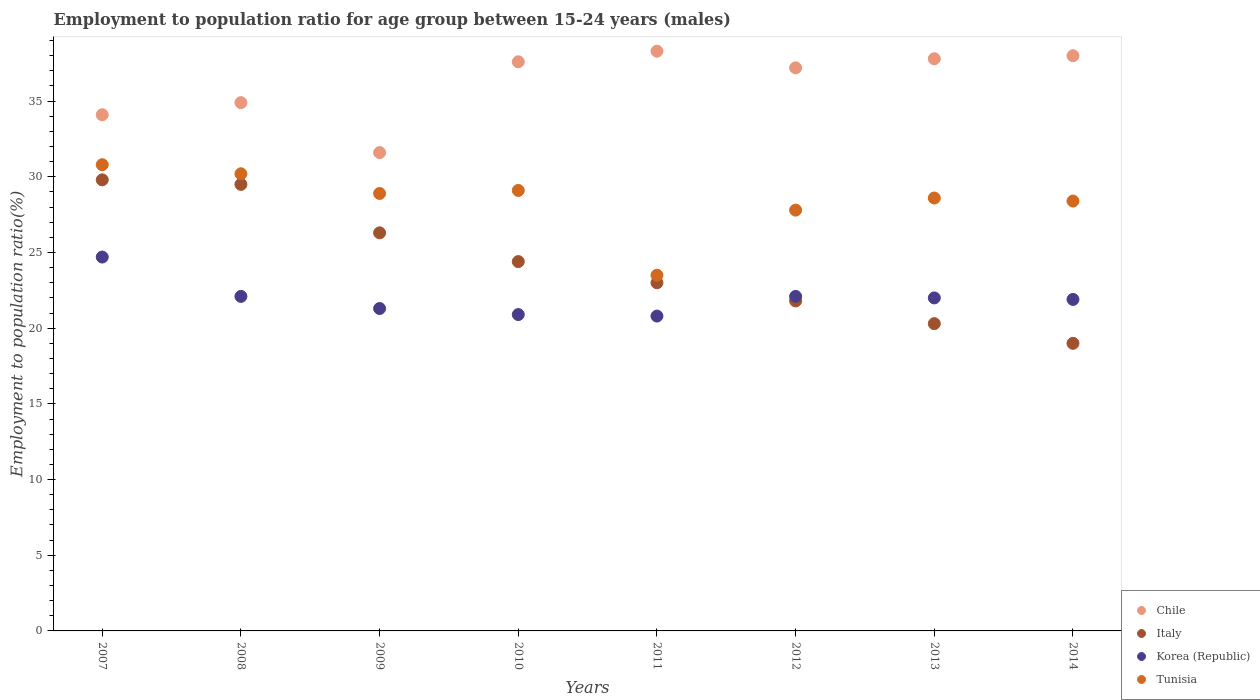Is the number of dotlines equal to the number of legend labels?
Your answer should be compact. Yes. What is the employment to population ratio in Italy in 2014?
Your answer should be very brief. 19. Across all years, what is the maximum employment to population ratio in Italy?
Your response must be concise. 29.8. Across all years, what is the minimum employment to population ratio in Korea (Republic)?
Your answer should be very brief. 20.8. In which year was the employment to population ratio in Korea (Republic) minimum?
Your answer should be very brief. 2011. What is the total employment to population ratio in Italy in the graph?
Your answer should be very brief. 194.1. What is the difference between the employment to population ratio in Korea (Republic) in 2011 and that in 2013?
Make the answer very short. -1.2. What is the difference between the employment to population ratio in Korea (Republic) in 2011 and the employment to population ratio in Italy in 2008?
Ensure brevity in your answer.  -8.7. What is the average employment to population ratio in Tunisia per year?
Offer a very short reply. 28.41. In the year 2011, what is the difference between the employment to population ratio in Italy and employment to population ratio in Korea (Republic)?
Make the answer very short. 2.2. What is the ratio of the employment to population ratio in Tunisia in 2008 to that in 2009?
Your answer should be very brief. 1.04. What is the difference between the highest and the second highest employment to population ratio in Chile?
Your answer should be very brief. 0.3. What is the difference between the highest and the lowest employment to population ratio in Korea (Republic)?
Offer a very short reply. 3.9. Is the sum of the employment to population ratio in Chile in 2007 and 2011 greater than the maximum employment to population ratio in Italy across all years?
Ensure brevity in your answer.  Yes. Is it the case that in every year, the sum of the employment to population ratio in Chile and employment to population ratio in Tunisia  is greater than the employment to population ratio in Korea (Republic)?
Your response must be concise. Yes. Does the employment to population ratio in Tunisia monotonically increase over the years?
Your response must be concise. No. Is the employment to population ratio in Chile strictly greater than the employment to population ratio in Tunisia over the years?
Your answer should be very brief. Yes. Are the values on the major ticks of Y-axis written in scientific E-notation?
Offer a very short reply. No. Does the graph contain any zero values?
Keep it short and to the point. No. How are the legend labels stacked?
Your response must be concise. Vertical. What is the title of the graph?
Offer a terse response. Employment to population ratio for age group between 15-24 years (males). Does "Middle East & North Africa (all income levels)" appear as one of the legend labels in the graph?
Your answer should be very brief. No. What is the label or title of the X-axis?
Make the answer very short. Years. What is the Employment to population ratio(%) of Chile in 2007?
Offer a terse response. 34.1. What is the Employment to population ratio(%) in Italy in 2007?
Your answer should be compact. 29.8. What is the Employment to population ratio(%) of Korea (Republic) in 2007?
Your response must be concise. 24.7. What is the Employment to population ratio(%) in Tunisia in 2007?
Provide a short and direct response. 30.8. What is the Employment to population ratio(%) of Chile in 2008?
Your response must be concise. 34.9. What is the Employment to population ratio(%) in Italy in 2008?
Offer a very short reply. 29.5. What is the Employment to population ratio(%) in Korea (Republic) in 2008?
Your answer should be compact. 22.1. What is the Employment to population ratio(%) in Tunisia in 2008?
Offer a terse response. 30.2. What is the Employment to population ratio(%) of Chile in 2009?
Keep it short and to the point. 31.6. What is the Employment to population ratio(%) of Italy in 2009?
Make the answer very short. 26.3. What is the Employment to population ratio(%) of Korea (Republic) in 2009?
Your answer should be very brief. 21.3. What is the Employment to population ratio(%) of Tunisia in 2009?
Give a very brief answer. 28.9. What is the Employment to population ratio(%) of Chile in 2010?
Keep it short and to the point. 37.6. What is the Employment to population ratio(%) of Italy in 2010?
Provide a short and direct response. 24.4. What is the Employment to population ratio(%) in Korea (Republic) in 2010?
Your answer should be very brief. 20.9. What is the Employment to population ratio(%) in Tunisia in 2010?
Make the answer very short. 29.1. What is the Employment to population ratio(%) in Chile in 2011?
Your answer should be very brief. 38.3. What is the Employment to population ratio(%) of Korea (Republic) in 2011?
Keep it short and to the point. 20.8. What is the Employment to population ratio(%) in Chile in 2012?
Make the answer very short. 37.2. What is the Employment to population ratio(%) of Italy in 2012?
Offer a terse response. 21.8. What is the Employment to population ratio(%) in Korea (Republic) in 2012?
Make the answer very short. 22.1. What is the Employment to population ratio(%) of Tunisia in 2012?
Make the answer very short. 27.8. What is the Employment to population ratio(%) of Chile in 2013?
Your response must be concise. 37.8. What is the Employment to population ratio(%) in Italy in 2013?
Ensure brevity in your answer.  20.3. What is the Employment to population ratio(%) in Tunisia in 2013?
Provide a short and direct response. 28.6. What is the Employment to population ratio(%) of Chile in 2014?
Keep it short and to the point. 38. What is the Employment to population ratio(%) in Korea (Republic) in 2014?
Provide a succinct answer. 21.9. What is the Employment to population ratio(%) in Tunisia in 2014?
Make the answer very short. 28.4. Across all years, what is the maximum Employment to population ratio(%) of Chile?
Keep it short and to the point. 38.3. Across all years, what is the maximum Employment to population ratio(%) of Italy?
Ensure brevity in your answer.  29.8. Across all years, what is the maximum Employment to population ratio(%) of Korea (Republic)?
Your answer should be very brief. 24.7. Across all years, what is the maximum Employment to population ratio(%) of Tunisia?
Provide a succinct answer. 30.8. Across all years, what is the minimum Employment to population ratio(%) of Chile?
Provide a short and direct response. 31.6. Across all years, what is the minimum Employment to population ratio(%) of Korea (Republic)?
Keep it short and to the point. 20.8. Across all years, what is the minimum Employment to population ratio(%) in Tunisia?
Offer a very short reply. 23.5. What is the total Employment to population ratio(%) of Chile in the graph?
Give a very brief answer. 289.5. What is the total Employment to population ratio(%) of Italy in the graph?
Provide a succinct answer. 194.1. What is the total Employment to population ratio(%) of Korea (Republic) in the graph?
Your answer should be very brief. 175.8. What is the total Employment to population ratio(%) in Tunisia in the graph?
Your response must be concise. 227.3. What is the difference between the Employment to population ratio(%) of Chile in 2007 and that in 2008?
Offer a very short reply. -0.8. What is the difference between the Employment to population ratio(%) in Korea (Republic) in 2007 and that in 2008?
Provide a short and direct response. 2.6. What is the difference between the Employment to population ratio(%) in Tunisia in 2007 and that in 2008?
Your response must be concise. 0.6. What is the difference between the Employment to population ratio(%) in Italy in 2007 and that in 2009?
Your response must be concise. 3.5. What is the difference between the Employment to population ratio(%) in Chile in 2007 and that in 2010?
Offer a terse response. -3.5. What is the difference between the Employment to population ratio(%) in Italy in 2007 and that in 2010?
Ensure brevity in your answer.  5.4. What is the difference between the Employment to population ratio(%) in Tunisia in 2007 and that in 2010?
Offer a very short reply. 1.7. What is the difference between the Employment to population ratio(%) of Chile in 2007 and that in 2011?
Keep it short and to the point. -4.2. What is the difference between the Employment to population ratio(%) in Korea (Republic) in 2007 and that in 2011?
Provide a succinct answer. 3.9. What is the difference between the Employment to population ratio(%) in Italy in 2007 and that in 2012?
Your response must be concise. 8. What is the difference between the Employment to population ratio(%) in Tunisia in 2007 and that in 2012?
Ensure brevity in your answer.  3. What is the difference between the Employment to population ratio(%) of Tunisia in 2007 and that in 2013?
Your response must be concise. 2.2. What is the difference between the Employment to population ratio(%) in Chile in 2007 and that in 2014?
Keep it short and to the point. -3.9. What is the difference between the Employment to population ratio(%) in Korea (Republic) in 2007 and that in 2014?
Provide a succinct answer. 2.8. What is the difference between the Employment to population ratio(%) of Chile in 2008 and that in 2010?
Make the answer very short. -2.7. What is the difference between the Employment to population ratio(%) of Korea (Republic) in 2008 and that in 2010?
Keep it short and to the point. 1.2. What is the difference between the Employment to population ratio(%) of Chile in 2008 and that in 2011?
Your response must be concise. -3.4. What is the difference between the Employment to population ratio(%) of Italy in 2008 and that in 2011?
Provide a short and direct response. 6.5. What is the difference between the Employment to population ratio(%) in Korea (Republic) in 2008 and that in 2011?
Offer a very short reply. 1.3. What is the difference between the Employment to population ratio(%) in Italy in 2008 and that in 2014?
Your answer should be very brief. 10.5. What is the difference between the Employment to population ratio(%) in Chile in 2009 and that in 2010?
Your response must be concise. -6. What is the difference between the Employment to population ratio(%) of Korea (Republic) in 2009 and that in 2010?
Your answer should be compact. 0.4. What is the difference between the Employment to population ratio(%) in Italy in 2009 and that in 2011?
Make the answer very short. 3.3. What is the difference between the Employment to population ratio(%) of Korea (Republic) in 2009 and that in 2011?
Offer a very short reply. 0.5. What is the difference between the Employment to population ratio(%) of Tunisia in 2009 and that in 2011?
Ensure brevity in your answer.  5.4. What is the difference between the Employment to population ratio(%) in Italy in 2009 and that in 2012?
Provide a short and direct response. 4.5. What is the difference between the Employment to population ratio(%) of Chile in 2009 and that in 2013?
Give a very brief answer. -6.2. What is the difference between the Employment to population ratio(%) in Italy in 2009 and that in 2013?
Give a very brief answer. 6. What is the difference between the Employment to population ratio(%) of Korea (Republic) in 2009 and that in 2013?
Offer a terse response. -0.7. What is the difference between the Employment to population ratio(%) in Chile in 2009 and that in 2014?
Your answer should be very brief. -6.4. What is the difference between the Employment to population ratio(%) in Korea (Republic) in 2009 and that in 2014?
Provide a short and direct response. -0.6. What is the difference between the Employment to population ratio(%) in Tunisia in 2009 and that in 2014?
Ensure brevity in your answer.  0.5. What is the difference between the Employment to population ratio(%) of Korea (Republic) in 2010 and that in 2012?
Your response must be concise. -1.2. What is the difference between the Employment to population ratio(%) of Tunisia in 2010 and that in 2012?
Your answer should be compact. 1.3. What is the difference between the Employment to population ratio(%) of Korea (Republic) in 2010 and that in 2013?
Your response must be concise. -1.1. What is the difference between the Employment to population ratio(%) in Tunisia in 2010 and that in 2013?
Make the answer very short. 0.5. What is the difference between the Employment to population ratio(%) in Korea (Republic) in 2010 and that in 2014?
Offer a very short reply. -1. What is the difference between the Employment to population ratio(%) of Tunisia in 2010 and that in 2014?
Offer a terse response. 0.7. What is the difference between the Employment to population ratio(%) in Chile in 2011 and that in 2012?
Your answer should be compact. 1.1. What is the difference between the Employment to population ratio(%) in Tunisia in 2011 and that in 2012?
Your response must be concise. -4.3. What is the difference between the Employment to population ratio(%) of Italy in 2011 and that in 2013?
Your response must be concise. 2.7. What is the difference between the Employment to population ratio(%) of Tunisia in 2011 and that in 2013?
Your response must be concise. -5.1. What is the difference between the Employment to population ratio(%) of Chile in 2011 and that in 2014?
Offer a terse response. 0.3. What is the difference between the Employment to population ratio(%) in Italy in 2011 and that in 2014?
Give a very brief answer. 4. What is the difference between the Employment to population ratio(%) of Korea (Republic) in 2011 and that in 2014?
Your response must be concise. -1.1. What is the difference between the Employment to population ratio(%) in Tunisia in 2011 and that in 2014?
Provide a succinct answer. -4.9. What is the difference between the Employment to population ratio(%) of Korea (Republic) in 2012 and that in 2013?
Offer a terse response. 0.1. What is the difference between the Employment to population ratio(%) of Tunisia in 2012 and that in 2013?
Offer a terse response. -0.8. What is the difference between the Employment to population ratio(%) in Italy in 2012 and that in 2014?
Ensure brevity in your answer.  2.8. What is the difference between the Employment to population ratio(%) of Korea (Republic) in 2012 and that in 2014?
Give a very brief answer. 0.2. What is the difference between the Employment to population ratio(%) in Korea (Republic) in 2013 and that in 2014?
Offer a terse response. 0.1. What is the difference between the Employment to population ratio(%) of Chile in 2007 and the Employment to population ratio(%) of Italy in 2008?
Give a very brief answer. 4.6. What is the difference between the Employment to population ratio(%) in Chile in 2007 and the Employment to population ratio(%) in Korea (Republic) in 2008?
Your response must be concise. 12. What is the difference between the Employment to population ratio(%) of Italy in 2007 and the Employment to population ratio(%) of Korea (Republic) in 2008?
Offer a terse response. 7.7. What is the difference between the Employment to population ratio(%) in Italy in 2007 and the Employment to population ratio(%) in Tunisia in 2008?
Your response must be concise. -0.4. What is the difference between the Employment to population ratio(%) in Korea (Republic) in 2007 and the Employment to population ratio(%) in Tunisia in 2008?
Offer a terse response. -5.5. What is the difference between the Employment to population ratio(%) of Chile in 2007 and the Employment to population ratio(%) of Korea (Republic) in 2010?
Provide a short and direct response. 13.2. What is the difference between the Employment to population ratio(%) of Chile in 2007 and the Employment to population ratio(%) of Tunisia in 2010?
Make the answer very short. 5. What is the difference between the Employment to population ratio(%) of Italy in 2007 and the Employment to population ratio(%) of Tunisia in 2010?
Keep it short and to the point. 0.7. What is the difference between the Employment to population ratio(%) in Korea (Republic) in 2007 and the Employment to population ratio(%) in Tunisia in 2010?
Your answer should be very brief. -4.4. What is the difference between the Employment to population ratio(%) in Chile in 2007 and the Employment to population ratio(%) in Italy in 2011?
Give a very brief answer. 11.1. What is the difference between the Employment to population ratio(%) of Chile in 2007 and the Employment to population ratio(%) of Korea (Republic) in 2011?
Your response must be concise. 13.3. What is the difference between the Employment to population ratio(%) of Korea (Republic) in 2007 and the Employment to population ratio(%) of Tunisia in 2011?
Provide a succinct answer. 1.2. What is the difference between the Employment to population ratio(%) in Chile in 2007 and the Employment to population ratio(%) in Italy in 2012?
Your answer should be very brief. 12.3. What is the difference between the Employment to population ratio(%) of Chile in 2007 and the Employment to population ratio(%) of Korea (Republic) in 2012?
Keep it short and to the point. 12. What is the difference between the Employment to population ratio(%) of Italy in 2007 and the Employment to population ratio(%) of Korea (Republic) in 2012?
Offer a terse response. 7.7. What is the difference between the Employment to population ratio(%) of Italy in 2007 and the Employment to population ratio(%) of Tunisia in 2012?
Offer a terse response. 2. What is the difference between the Employment to population ratio(%) in Chile in 2007 and the Employment to population ratio(%) in Italy in 2013?
Make the answer very short. 13.8. What is the difference between the Employment to population ratio(%) of Chile in 2007 and the Employment to population ratio(%) of Korea (Republic) in 2013?
Keep it short and to the point. 12.1. What is the difference between the Employment to population ratio(%) of Italy in 2007 and the Employment to population ratio(%) of Korea (Republic) in 2013?
Provide a succinct answer. 7.8. What is the difference between the Employment to population ratio(%) in Italy in 2007 and the Employment to population ratio(%) in Tunisia in 2013?
Your answer should be compact. 1.2. What is the difference between the Employment to population ratio(%) in Korea (Republic) in 2007 and the Employment to population ratio(%) in Tunisia in 2013?
Provide a short and direct response. -3.9. What is the difference between the Employment to population ratio(%) of Chile in 2007 and the Employment to population ratio(%) of Korea (Republic) in 2014?
Your answer should be compact. 12.2. What is the difference between the Employment to population ratio(%) in Chile in 2007 and the Employment to population ratio(%) in Tunisia in 2014?
Provide a succinct answer. 5.7. What is the difference between the Employment to population ratio(%) in Italy in 2007 and the Employment to population ratio(%) in Tunisia in 2014?
Give a very brief answer. 1.4. What is the difference between the Employment to population ratio(%) of Korea (Republic) in 2007 and the Employment to population ratio(%) of Tunisia in 2014?
Make the answer very short. -3.7. What is the difference between the Employment to population ratio(%) of Chile in 2008 and the Employment to population ratio(%) of Italy in 2009?
Offer a very short reply. 8.6. What is the difference between the Employment to population ratio(%) in Korea (Republic) in 2008 and the Employment to population ratio(%) in Tunisia in 2009?
Offer a very short reply. -6.8. What is the difference between the Employment to population ratio(%) of Chile in 2008 and the Employment to population ratio(%) of Tunisia in 2010?
Make the answer very short. 5.8. What is the difference between the Employment to population ratio(%) in Italy in 2008 and the Employment to population ratio(%) in Tunisia in 2010?
Offer a terse response. 0.4. What is the difference between the Employment to population ratio(%) in Korea (Republic) in 2008 and the Employment to population ratio(%) in Tunisia in 2010?
Provide a succinct answer. -7. What is the difference between the Employment to population ratio(%) of Chile in 2008 and the Employment to population ratio(%) of Italy in 2011?
Provide a succinct answer. 11.9. What is the difference between the Employment to population ratio(%) in Chile in 2008 and the Employment to population ratio(%) in Tunisia in 2011?
Your response must be concise. 11.4. What is the difference between the Employment to population ratio(%) of Korea (Republic) in 2008 and the Employment to population ratio(%) of Tunisia in 2012?
Give a very brief answer. -5.7. What is the difference between the Employment to population ratio(%) of Chile in 2008 and the Employment to population ratio(%) of Tunisia in 2013?
Your response must be concise. 6.3. What is the difference between the Employment to population ratio(%) of Italy in 2008 and the Employment to population ratio(%) of Tunisia in 2013?
Ensure brevity in your answer.  0.9. What is the difference between the Employment to population ratio(%) of Chile in 2008 and the Employment to population ratio(%) of Italy in 2014?
Your answer should be very brief. 15.9. What is the difference between the Employment to population ratio(%) in Chile in 2008 and the Employment to population ratio(%) in Tunisia in 2014?
Your response must be concise. 6.5. What is the difference between the Employment to population ratio(%) of Italy in 2008 and the Employment to population ratio(%) of Korea (Republic) in 2014?
Your answer should be compact. 7.6. What is the difference between the Employment to population ratio(%) in Korea (Republic) in 2008 and the Employment to population ratio(%) in Tunisia in 2014?
Ensure brevity in your answer.  -6.3. What is the difference between the Employment to population ratio(%) in Chile in 2009 and the Employment to population ratio(%) in Italy in 2010?
Keep it short and to the point. 7.2. What is the difference between the Employment to population ratio(%) of Chile in 2009 and the Employment to population ratio(%) of Korea (Republic) in 2010?
Offer a terse response. 10.7. What is the difference between the Employment to population ratio(%) in Italy in 2009 and the Employment to population ratio(%) in Tunisia in 2010?
Your answer should be very brief. -2.8. What is the difference between the Employment to population ratio(%) of Korea (Republic) in 2009 and the Employment to population ratio(%) of Tunisia in 2010?
Give a very brief answer. -7.8. What is the difference between the Employment to population ratio(%) of Chile in 2009 and the Employment to population ratio(%) of Tunisia in 2011?
Make the answer very short. 8.1. What is the difference between the Employment to population ratio(%) of Italy in 2009 and the Employment to population ratio(%) of Korea (Republic) in 2011?
Provide a short and direct response. 5.5. What is the difference between the Employment to population ratio(%) in Italy in 2009 and the Employment to population ratio(%) in Tunisia in 2011?
Make the answer very short. 2.8. What is the difference between the Employment to population ratio(%) in Korea (Republic) in 2009 and the Employment to population ratio(%) in Tunisia in 2011?
Give a very brief answer. -2.2. What is the difference between the Employment to population ratio(%) in Chile in 2009 and the Employment to population ratio(%) in Italy in 2012?
Offer a terse response. 9.8. What is the difference between the Employment to population ratio(%) of Chile in 2009 and the Employment to population ratio(%) of Korea (Republic) in 2012?
Ensure brevity in your answer.  9.5. What is the difference between the Employment to population ratio(%) in Chile in 2009 and the Employment to population ratio(%) in Tunisia in 2012?
Provide a short and direct response. 3.8. What is the difference between the Employment to population ratio(%) of Italy in 2009 and the Employment to population ratio(%) of Tunisia in 2012?
Give a very brief answer. -1.5. What is the difference between the Employment to population ratio(%) in Chile in 2009 and the Employment to population ratio(%) in Korea (Republic) in 2013?
Offer a very short reply. 9.6. What is the difference between the Employment to population ratio(%) of Chile in 2009 and the Employment to population ratio(%) of Tunisia in 2013?
Your answer should be very brief. 3. What is the difference between the Employment to population ratio(%) of Italy in 2009 and the Employment to population ratio(%) of Korea (Republic) in 2013?
Provide a succinct answer. 4.3. What is the difference between the Employment to population ratio(%) of Italy in 2009 and the Employment to population ratio(%) of Tunisia in 2013?
Your response must be concise. -2.3. What is the difference between the Employment to population ratio(%) in Chile in 2009 and the Employment to population ratio(%) in Italy in 2014?
Provide a succinct answer. 12.6. What is the difference between the Employment to population ratio(%) in Italy in 2009 and the Employment to population ratio(%) in Korea (Republic) in 2014?
Provide a succinct answer. 4.4. What is the difference between the Employment to population ratio(%) in Korea (Republic) in 2009 and the Employment to population ratio(%) in Tunisia in 2014?
Make the answer very short. -7.1. What is the difference between the Employment to population ratio(%) of Italy in 2010 and the Employment to population ratio(%) of Korea (Republic) in 2011?
Provide a short and direct response. 3.6. What is the difference between the Employment to population ratio(%) of Italy in 2010 and the Employment to population ratio(%) of Tunisia in 2011?
Your answer should be compact. 0.9. What is the difference between the Employment to population ratio(%) of Chile in 2010 and the Employment to population ratio(%) of Korea (Republic) in 2012?
Provide a succinct answer. 15.5. What is the difference between the Employment to population ratio(%) of Korea (Republic) in 2010 and the Employment to population ratio(%) of Tunisia in 2012?
Give a very brief answer. -6.9. What is the difference between the Employment to population ratio(%) of Chile in 2010 and the Employment to population ratio(%) of Korea (Republic) in 2013?
Your response must be concise. 15.6. What is the difference between the Employment to population ratio(%) of Chile in 2010 and the Employment to population ratio(%) of Tunisia in 2013?
Offer a very short reply. 9. What is the difference between the Employment to population ratio(%) of Italy in 2010 and the Employment to population ratio(%) of Tunisia in 2013?
Your answer should be very brief. -4.2. What is the difference between the Employment to population ratio(%) in Korea (Republic) in 2010 and the Employment to population ratio(%) in Tunisia in 2013?
Give a very brief answer. -7.7. What is the difference between the Employment to population ratio(%) of Chile in 2010 and the Employment to population ratio(%) of Italy in 2014?
Offer a terse response. 18.6. What is the difference between the Employment to population ratio(%) in Chile in 2010 and the Employment to population ratio(%) in Korea (Republic) in 2014?
Provide a short and direct response. 15.7. What is the difference between the Employment to population ratio(%) in Chile in 2010 and the Employment to population ratio(%) in Tunisia in 2014?
Offer a very short reply. 9.2. What is the difference between the Employment to population ratio(%) in Italy in 2010 and the Employment to population ratio(%) in Tunisia in 2014?
Provide a short and direct response. -4. What is the difference between the Employment to population ratio(%) in Chile in 2011 and the Employment to population ratio(%) in Korea (Republic) in 2012?
Your answer should be compact. 16.2. What is the difference between the Employment to population ratio(%) of Chile in 2011 and the Employment to population ratio(%) of Tunisia in 2012?
Make the answer very short. 10.5. What is the difference between the Employment to population ratio(%) of Italy in 2011 and the Employment to population ratio(%) of Korea (Republic) in 2013?
Keep it short and to the point. 1. What is the difference between the Employment to population ratio(%) of Italy in 2011 and the Employment to population ratio(%) of Tunisia in 2013?
Make the answer very short. -5.6. What is the difference between the Employment to population ratio(%) of Korea (Republic) in 2011 and the Employment to population ratio(%) of Tunisia in 2013?
Keep it short and to the point. -7.8. What is the difference between the Employment to population ratio(%) in Chile in 2011 and the Employment to population ratio(%) in Italy in 2014?
Keep it short and to the point. 19.3. What is the difference between the Employment to population ratio(%) of Chile in 2011 and the Employment to population ratio(%) of Korea (Republic) in 2014?
Keep it short and to the point. 16.4. What is the difference between the Employment to population ratio(%) of Italy in 2011 and the Employment to population ratio(%) of Korea (Republic) in 2014?
Provide a short and direct response. 1.1. What is the difference between the Employment to population ratio(%) of Chile in 2012 and the Employment to population ratio(%) of Italy in 2013?
Provide a short and direct response. 16.9. What is the difference between the Employment to population ratio(%) in Chile in 2012 and the Employment to population ratio(%) in Korea (Republic) in 2013?
Offer a very short reply. 15.2. What is the difference between the Employment to population ratio(%) in Italy in 2012 and the Employment to population ratio(%) in Tunisia in 2013?
Provide a short and direct response. -6.8. What is the difference between the Employment to population ratio(%) of Chile in 2012 and the Employment to population ratio(%) of Korea (Republic) in 2014?
Offer a very short reply. 15.3. What is the difference between the Employment to population ratio(%) of Chile in 2012 and the Employment to population ratio(%) of Tunisia in 2014?
Provide a short and direct response. 8.8. What is the difference between the Employment to population ratio(%) in Italy in 2012 and the Employment to population ratio(%) in Korea (Republic) in 2014?
Your answer should be very brief. -0.1. What is the difference between the Employment to population ratio(%) of Korea (Republic) in 2012 and the Employment to population ratio(%) of Tunisia in 2014?
Provide a succinct answer. -6.3. What is the difference between the Employment to population ratio(%) of Chile in 2013 and the Employment to population ratio(%) of Tunisia in 2014?
Offer a terse response. 9.4. What is the difference between the Employment to population ratio(%) of Italy in 2013 and the Employment to population ratio(%) of Korea (Republic) in 2014?
Offer a terse response. -1.6. What is the average Employment to population ratio(%) of Chile per year?
Your answer should be very brief. 36.19. What is the average Employment to population ratio(%) of Italy per year?
Make the answer very short. 24.26. What is the average Employment to population ratio(%) of Korea (Republic) per year?
Provide a succinct answer. 21.98. What is the average Employment to population ratio(%) of Tunisia per year?
Provide a short and direct response. 28.41. In the year 2007, what is the difference between the Employment to population ratio(%) of Chile and Employment to population ratio(%) of Korea (Republic)?
Your answer should be very brief. 9.4. In the year 2007, what is the difference between the Employment to population ratio(%) of Chile and Employment to population ratio(%) of Tunisia?
Offer a terse response. 3.3. In the year 2007, what is the difference between the Employment to population ratio(%) in Italy and Employment to population ratio(%) in Korea (Republic)?
Keep it short and to the point. 5.1. In the year 2007, what is the difference between the Employment to population ratio(%) in Korea (Republic) and Employment to population ratio(%) in Tunisia?
Give a very brief answer. -6.1. In the year 2008, what is the difference between the Employment to population ratio(%) of Chile and Employment to population ratio(%) of Italy?
Offer a terse response. 5.4. In the year 2008, what is the difference between the Employment to population ratio(%) in Italy and Employment to population ratio(%) in Korea (Republic)?
Your response must be concise. 7.4. In the year 2008, what is the difference between the Employment to population ratio(%) in Korea (Republic) and Employment to population ratio(%) in Tunisia?
Make the answer very short. -8.1. In the year 2009, what is the difference between the Employment to population ratio(%) in Chile and Employment to population ratio(%) in Tunisia?
Keep it short and to the point. 2.7. In the year 2009, what is the difference between the Employment to population ratio(%) of Italy and Employment to population ratio(%) of Korea (Republic)?
Provide a short and direct response. 5. In the year 2009, what is the difference between the Employment to population ratio(%) of Italy and Employment to population ratio(%) of Tunisia?
Give a very brief answer. -2.6. In the year 2010, what is the difference between the Employment to population ratio(%) of Chile and Employment to population ratio(%) of Tunisia?
Your answer should be compact. 8.5. In the year 2011, what is the difference between the Employment to population ratio(%) in Chile and Employment to population ratio(%) in Korea (Republic)?
Your answer should be compact. 17.5. In the year 2011, what is the difference between the Employment to population ratio(%) of Chile and Employment to population ratio(%) of Tunisia?
Your answer should be compact. 14.8. In the year 2011, what is the difference between the Employment to population ratio(%) in Italy and Employment to population ratio(%) in Korea (Republic)?
Your response must be concise. 2.2. In the year 2012, what is the difference between the Employment to population ratio(%) of Chile and Employment to population ratio(%) of Italy?
Give a very brief answer. 15.4. In the year 2012, what is the difference between the Employment to population ratio(%) in Chile and Employment to population ratio(%) in Tunisia?
Ensure brevity in your answer.  9.4. In the year 2012, what is the difference between the Employment to population ratio(%) of Italy and Employment to population ratio(%) of Korea (Republic)?
Give a very brief answer. -0.3. In the year 2012, what is the difference between the Employment to population ratio(%) in Korea (Republic) and Employment to population ratio(%) in Tunisia?
Provide a short and direct response. -5.7. In the year 2013, what is the difference between the Employment to population ratio(%) in Chile and Employment to population ratio(%) in Italy?
Keep it short and to the point. 17.5. In the year 2013, what is the difference between the Employment to population ratio(%) in Chile and Employment to population ratio(%) in Korea (Republic)?
Keep it short and to the point. 15.8. In the year 2013, what is the difference between the Employment to population ratio(%) in Chile and Employment to population ratio(%) in Tunisia?
Give a very brief answer. 9.2. In the year 2014, what is the difference between the Employment to population ratio(%) of Chile and Employment to population ratio(%) of Korea (Republic)?
Make the answer very short. 16.1. In the year 2014, what is the difference between the Employment to population ratio(%) of Chile and Employment to population ratio(%) of Tunisia?
Offer a very short reply. 9.6. In the year 2014, what is the difference between the Employment to population ratio(%) in Italy and Employment to population ratio(%) in Korea (Republic)?
Your response must be concise. -2.9. In the year 2014, what is the difference between the Employment to population ratio(%) of Korea (Republic) and Employment to population ratio(%) of Tunisia?
Your answer should be compact. -6.5. What is the ratio of the Employment to population ratio(%) in Chile in 2007 to that in 2008?
Give a very brief answer. 0.98. What is the ratio of the Employment to population ratio(%) of Italy in 2007 to that in 2008?
Your answer should be very brief. 1.01. What is the ratio of the Employment to population ratio(%) of Korea (Republic) in 2007 to that in 2008?
Your answer should be very brief. 1.12. What is the ratio of the Employment to population ratio(%) in Tunisia in 2007 to that in 2008?
Your response must be concise. 1.02. What is the ratio of the Employment to population ratio(%) of Chile in 2007 to that in 2009?
Keep it short and to the point. 1.08. What is the ratio of the Employment to population ratio(%) of Italy in 2007 to that in 2009?
Your response must be concise. 1.13. What is the ratio of the Employment to population ratio(%) of Korea (Republic) in 2007 to that in 2009?
Your response must be concise. 1.16. What is the ratio of the Employment to population ratio(%) of Tunisia in 2007 to that in 2009?
Offer a terse response. 1.07. What is the ratio of the Employment to population ratio(%) of Chile in 2007 to that in 2010?
Provide a succinct answer. 0.91. What is the ratio of the Employment to population ratio(%) in Italy in 2007 to that in 2010?
Provide a short and direct response. 1.22. What is the ratio of the Employment to population ratio(%) of Korea (Republic) in 2007 to that in 2010?
Make the answer very short. 1.18. What is the ratio of the Employment to population ratio(%) of Tunisia in 2007 to that in 2010?
Offer a very short reply. 1.06. What is the ratio of the Employment to population ratio(%) of Chile in 2007 to that in 2011?
Provide a succinct answer. 0.89. What is the ratio of the Employment to population ratio(%) in Italy in 2007 to that in 2011?
Offer a very short reply. 1.3. What is the ratio of the Employment to population ratio(%) of Korea (Republic) in 2007 to that in 2011?
Give a very brief answer. 1.19. What is the ratio of the Employment to population ratio(%) of Tunisia in 2007 to that in 2011?
Your answer should be compact. 1.31. What is the ratio of the Employment to population ratio(%) of Italy in 2007 to that in 2012?
Offer a very short reply. 1.37. What is the ratio of the Employment to population ratio(%) of Korea (Republic) in 2007 to that in 2012?
Provide a short and direct response. 1.12. What is the ratio of the Employment to population ratio(%) of Tunisia in 2007 to that in 2012?
Offer a terse response. 1.11. What is the ratio of the Employment to population ratio(%) of Chile in 2007 to that in 2013?
Offer a terse response. 0.9. What is the ratio of the Employment to population ratio(%) in Italy in 2007 to that in 2013?
Offer a terse response. 1.47. What is the ratio of the Employment to population ratio(%) of Korea (Republic) in 2007 to that in 2013?
Offer a terse response. 1.12. What is the ratio of the Employment to population ratio(%) of Tunisia in 2007 to that in 2013?
Ensure brevity in your answer.  1.08. What is the ratio of the Employment to population ratio(%) in Chile in 2007 to that in 2014?
Make the answer very short. 0.9. What is the ratio of the Employment to population ratio(%) in Italy in 2007 to that in 2014?
Offer a very short reply. 1.57. What is the ratio of the Employment to population ratio(%) in Korea (Republic) in 2007 to that in 2014?
Keep it short and to the point. 1.13. What is the ratio of the Employment to population ratio(%) in Tunisia in 2007 to that in 2014?
Offer a very short reply. 1.08. What is the ratio of the Employment to population ratio(%) of Chile in 2008 to that in 2009?
Your answer should be compact. 1.1. What is the ratio of the Employment to population ratio(%) of Italy in 2008 to that in 2009?
Give a very brief answer. 1.12. What is the ratio of the Employment to population ratio(%) in Korea (Republic) in 2008 to that in 2009?
Give a very brief answer. 1.04. What is the ratio of the Employment to population ratio(%) of Tunisia in 2008 to that in 2009?
Keep it short and to the point. 1.04. What is the ratio of the Employment to population ratio(%) of Chile in 2008 to that in 2010?
Offer a very short reply. 0.93. What is the ratio of the Employment to population ratio(%) of Italy in 2008 to that in 2010?
Offer a terse response. 1.21. What is the ratio of the Employment to population ratio(%) of Korea (Republic) in 2008 to that in 2010?
Your answer should be compact. 1.06. What is the ratio of the Employment to population ratio(%) of Tunisia in 2008 to that in 2010?
Your response must be concise. 1.04. What is the ratio of the Employment to population ratio(%) of Chile in 2008 to that in 2011?
Give a very brief answer. 0.91. What is the ratio of the Employment to population ratio(%) of Italy in 2008 to that in 2011?
Make the answer very short. 1.28. What is the ratio of the Employment to population ratio(%) in Tunisia in 2008 to that in 2011?
Offer a very short reply. 1.29. What is the ratio of the Employment to population ratio(%) in Chile in 2008 to that in 2012?
Give a very brief answer. 0.94. What is the ratio of the Employment to population ratio(%) in Italy in 2008 to that in 2012?
Ensure brevity in your answer.  1.35. What is the ratio of the Employment to population ratio(%) in Korea (Republic) in 2008 to that in 2012?
Provide a succinct answer. 1. What is the ratio of the Employment to population ratio(%) of Tunisia in 2008 to that in 2012?
Make the answer very short. 1.09. What is the ratio of the Employment to population ratio(%) in Chile in 2008 to that in 2013?
Your answer should be compact. 0.92. What is the ratio of the Employment to population ratio(%) of Italy in 2008 to that in 2013?
Provide a short and direct response. 1.45. What is the ratio of the Employment to population ratio(%) in Tunisia in 2008 to that in 2013?
Your response must be concise. 1.06. What is the ratio of the Employment to population ratio(%) of Chile in 2008 to that in 2014?
Your answer should be compact. 0.92. What is the ratio of the Employment to population ratio(%) in Italy in 2008 to that in 2014?
Give a very brief answer. 1.55. What is the ratio of the Employment to population ratio(%) of Korea (Republic) in 2008 to that in 2014?
Your answer should be compact. 1.01. What is the ratio of the Employment to population ratio(%) of Tunisia in 2008 to that in 2014?
Provide a succinct answer. 1.06. What is the ratio of the Employment to population ratio(%) of Chile in 2009 to that in 2010?
Provide a succinct answer. 0.84. What is the ratio of the Employment to population ratio(%) of Italy in 2009 to that in 2010?
Offer a very short reply. 1.08. What is the ratio of the Employment to population ratio(%) in Korea (Republic) in 2009 to that in 2010?
Your answer should be compact. 1.02. What is the ratio of the Employment to population ratio(%) in Chile in 2009 to that in 2011?
Make the answer very short. 0.83. What is the ratio of the Employment to population ratio(%) in Italy in 2009 to that in 2011?
Ensure brevity in your answer.  1.14. What is the ratio of the Employment to population ratio(%) in Korea (Republic) in 2009 to that in 2011?
Make the answer very short. 1.02. What is the ratio of the Employment to population ratio(%) of Tunisia in 2009 to that in 2011?
Your response must be concise. 1.23. What is the ratio of the Employment to population ratio(%) in Chile in 2009 to that in 2012?
Your answer should be very brief. 0.85. What is the ratio of the Employment to population ratio(%) in Italy in 2009 to that in 2012?
Provide a short and direct response. 1.21. What is the ratio of the Employment to population ratio(%) in Korea (Republic) in 2009 to that in 2012?
Give a very brief answer. 0.96. What is the ratio of the Employment to population ratio(%) in Tunisia in 2009 to that in 2012?
Your answer should be compact. 1.04. What is the ratio of the Employment to population ratio(%) of Chile in 2009 to that in 2013?
Make the answer very short. 0.84. What is the ratio of the Employment to population ratio(%) in Italy in 2009 to that in 2013?
Make the answer very short. 1.3. What is the ratio of the Employment to population ratio(%) in Korea (Republic) in 2009 to that in 2013?
Offer a terse response. 0.97. What is the ratio of the Employment to population ratio(%) in Tunisia in 2009 to that in 2013?
Your answer should be compact. 1.01. What is the ratio of the Employment to population ratio(%) of Chile in 2009 to that in 2014?
Give a very brief answer. 0.83. What is the ratio of the Employment to population ratio(%) in Italy in 2009 to that in 2014?
Your response must be concise. 1.38. What is the ratio of the Employment to population ratio(%) of Korea (Republic) in 2009 to that in 2014?
Your response must be concise. 0.97. What is the ratio of the Employment to population ratio(%) in Tunisia in 2009 to that in 2014?
Your answer should be compact. 1.02. What is the ratio of the Employment to population ratio(%) in Chile in 2010 to that in 2011?
Ensure brevity in your answer.  0.98. What is the ratio of the Employment to population ratio(%) in Italy in 2010 to that in 2011?
Provide a short and direct response. 1.06. What is the ratio of the Employment to population ratio(%) of Tunisia in 2010 to that in 2011?
Offer a very short reply. 1.24. What is the ratio of the Employment to population ratio(%) in Chile in 2010 to that in 2012?
Make the answer very short. 1.01. What is the ratio of the Employment to population ratio(%) in Italy in 2010 to that in 2012?
Offer a very short reply. 1.12. What is the ratio of the Employment to population ratio(%) in Korea (Republic) in 2010 to that in 2012?
Give a very brief answer. 0.95. What is the ratio of the Employment to population ratio(%) of Tunisia in 2010 to that in 2012?
Your answer should be compact. 1.05. What is the ratio of the Employment to population ratio(%) in Italy in 2010 to that in 2013?
Your response must be concise. 1.2. What is the ratio of the Employment to population ratio(%) in Korea (Republic) in 2010 to that in 2013?
Your response must be concise. 0.95. What is the ratio of the Employment to population ratio(%) in Tunisia in 2010 to that in 2013?
Provide a short and direct response. 1.02. What is the ratio of the Employment to population ratio(%) in Italy in 2010 to that in 2014?
Provide a succinct answer. 1.28. What is the ratio of the Employment to population ratio(%) in Korea (Republic) in 2010 to that in 2014?
Give a very brief answer. 0.95. What is the ratio of the Employment to population ratio(%) in Tunisia in 2010 to that in 2014?
Keep it short and to the point. 1.02. What is the ratio of the Employment to population ratio(%) in Chile in 2011 to that in 2012?
Offer a terse response. 1.03. What is the ratio of the Employment to population ratio(%) in Italy in 2011 to that in 2012?
Provide a short and direct response. 1.05. What is the ratio of the Employment to population ratio(%) of Korea (Republic) in 2011 to that in 2012?
Offer a very short reply. 0.94. What is the ratio of the Employment to population ratio(%) in Tunisia in 2011 to that in 2012?
Your answer should be very brief. 0.85. What is the ratio of the Employment to population ratio(%) of Chile in 2011 to that in 2013?
Give a very brief answer. 1.01. What is the ratio of the Employment to population ratio(%) in Italy in 2011 to that in 2013?
Give a very brief answer. 1.13. What is the ratio of the Employment to population ratio(%) of Korea (Republic) in 2011 to that in 2013?
Provide a short and direct response. 0.95. What is the ratio of the Employment to population ratio(%) in Tunisia in 2011 to that in 2013?
Ensure brevity in your answer.  0.82. What is the ratio of the Employment to population ratio(%) in Chile in 2011 to that in 2014?
Your answer should be very brief. 1.01. What is the ratio of the Employment to population ratio(%) of Italy in 2011 to that in 2014?
Your answer should be very brief. 1.21. What is the ratio of the Employment to population ratio(%) in Korea (Republic) in 2011 to that in 2014?
Provide a short and direct response. 0.95. What is the ratio of the Employment to population ratio(%) of Tunisia in 2011 to that in 2014?
Your answer should be compact. 0.83. What is the ratio of the Employment to population ratio(%) of Chile in 2012 to that in 2013?
Make the answer very short. 0.98. What is the ratio of the Employment to population ratio(%) in Italy in 2012 to that in 2013?
Provide a short and direct response. 1.07. What is the ratio of the Employment to population ratio(%) of Tunisia in 2012 to that in 2013?
Offer a very short reply. 0.97. What is the ratio of the Employment to population ratio(%) in Chile in 2012 to that in 2014?
Offer a very short reply. 0.98. What is the ratio of the Employment to population ratio(%) in Italy in 2012 to that in 2014?
Offer a terse response. 1.15. What is the ratio of the Employment to population ratio(%) of Korea (Republic) in 2012 to that in 2014?
Your answer should be compact. 1.01. What is the ratio of the Employment to population ratio(%) in Tunisia in 2012 to that in 2014?
Give a very brief answer. 0.98. What is the ratio of the Employment to population ratio(%) in Italy in 2013 to that in 2014?
Ensure brevity in your answer.  1.07. What is the ratio of the Employment to population ratio(%) of Korea (Republic) in 2013 to that in 2014?
Make the answer very short. 1. What is the difference between the highest and the second highest Employment to population ratio(%) in Chile?
Offer a very short reply. 0.3. What is the difference between the highest and the second highest Employment to population ratio(%) in Korea (Republic)?
Your answer should be very brief. 2.6. What is the difference between the highest and the second highest Employment to population ratio(%) of Tunisia?
Make the answer very short. 0.6. What is the difference between the highest and the lowest Employment to population ratio(%) in Chile?
Provide a succinct answer. 6.7. What is the difference between the highest and the lowest Employment to population ratio(%) of Tunisia?
Provide a short and direct response. 7.3. 